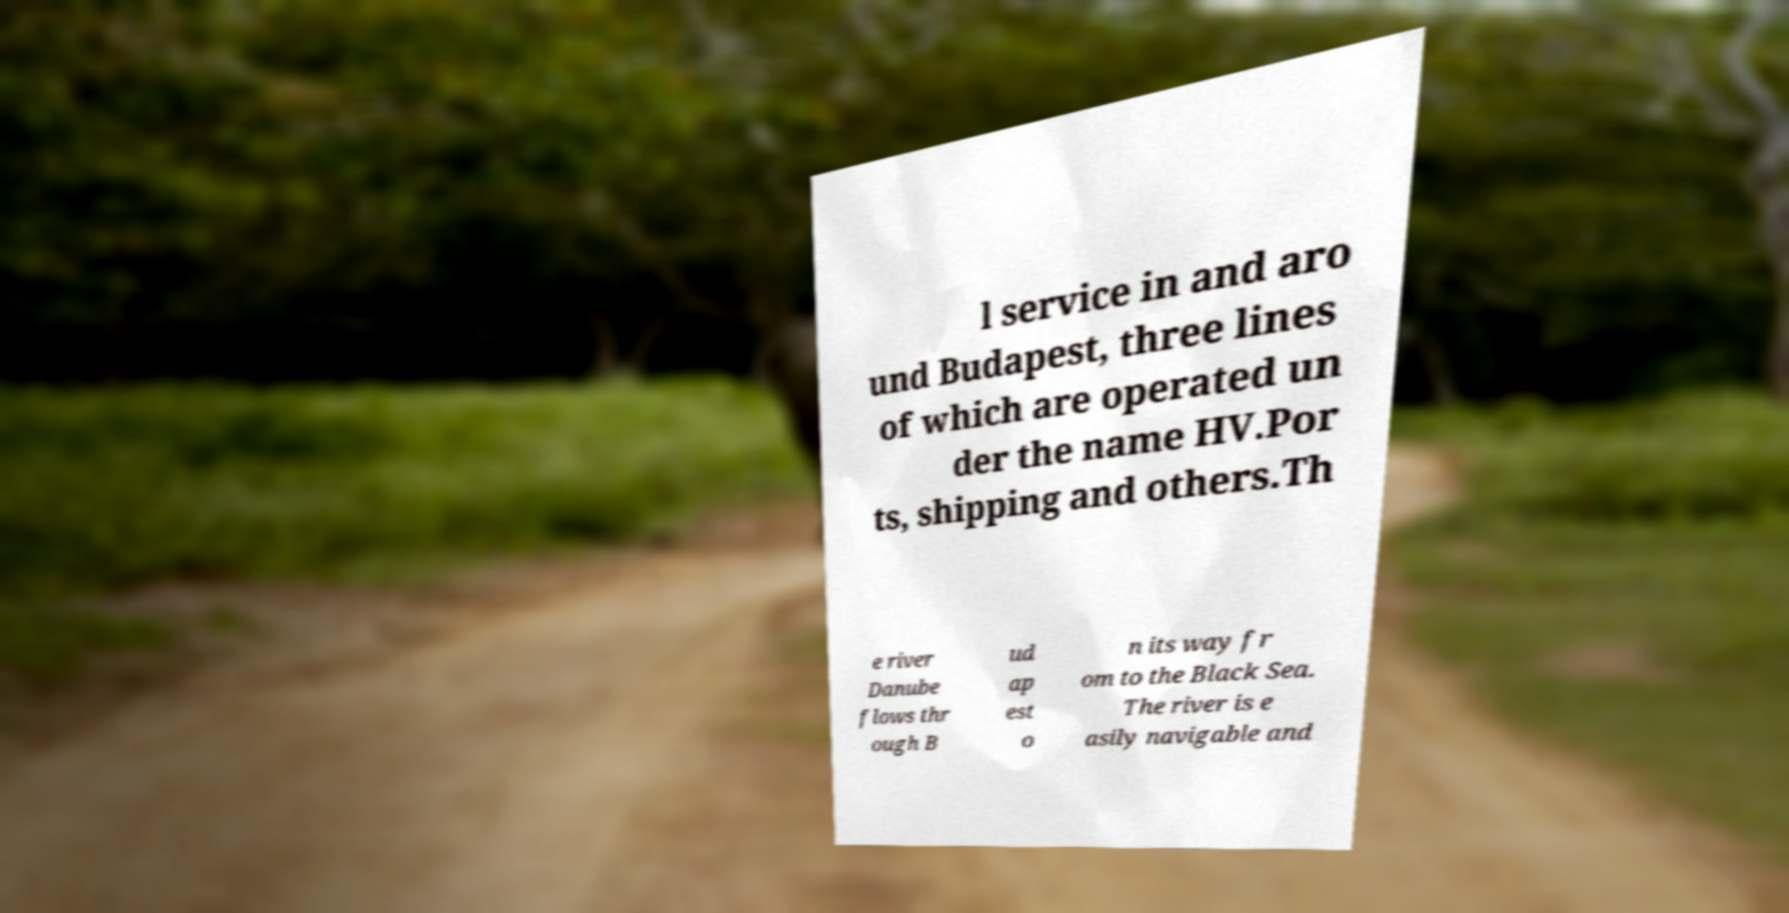Please read and relay the text visible in this image. What does it say? l service in and aro und Budapest, three lines of which are operated un der the name HV.Por ts, shipping and others.Th e river Danube flows thr ough B ud ap est o n its way fr om to the Black Sea. The river is e asily navigable and 